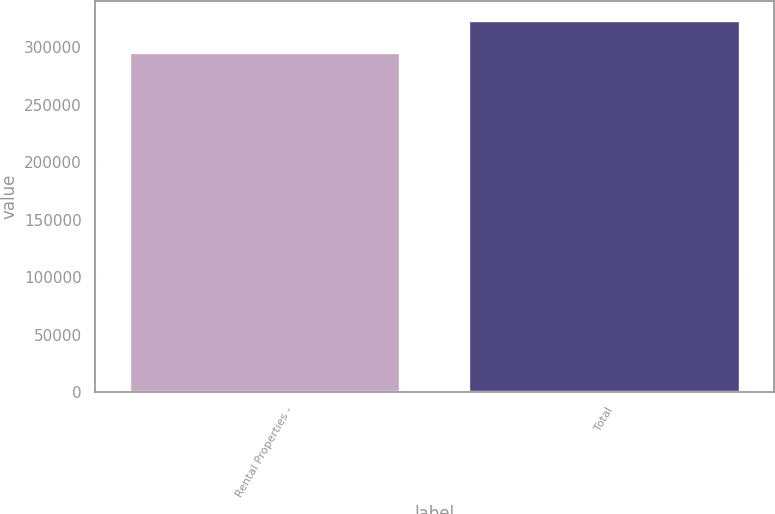Convert chart to OTSL. <chart><loc_0><loc_0><loc_500><loc_500><bar_chart><fcel>Rental Properties -<fcel>Total<nl><fcel>296037<fcel>323837<nl></chart> 